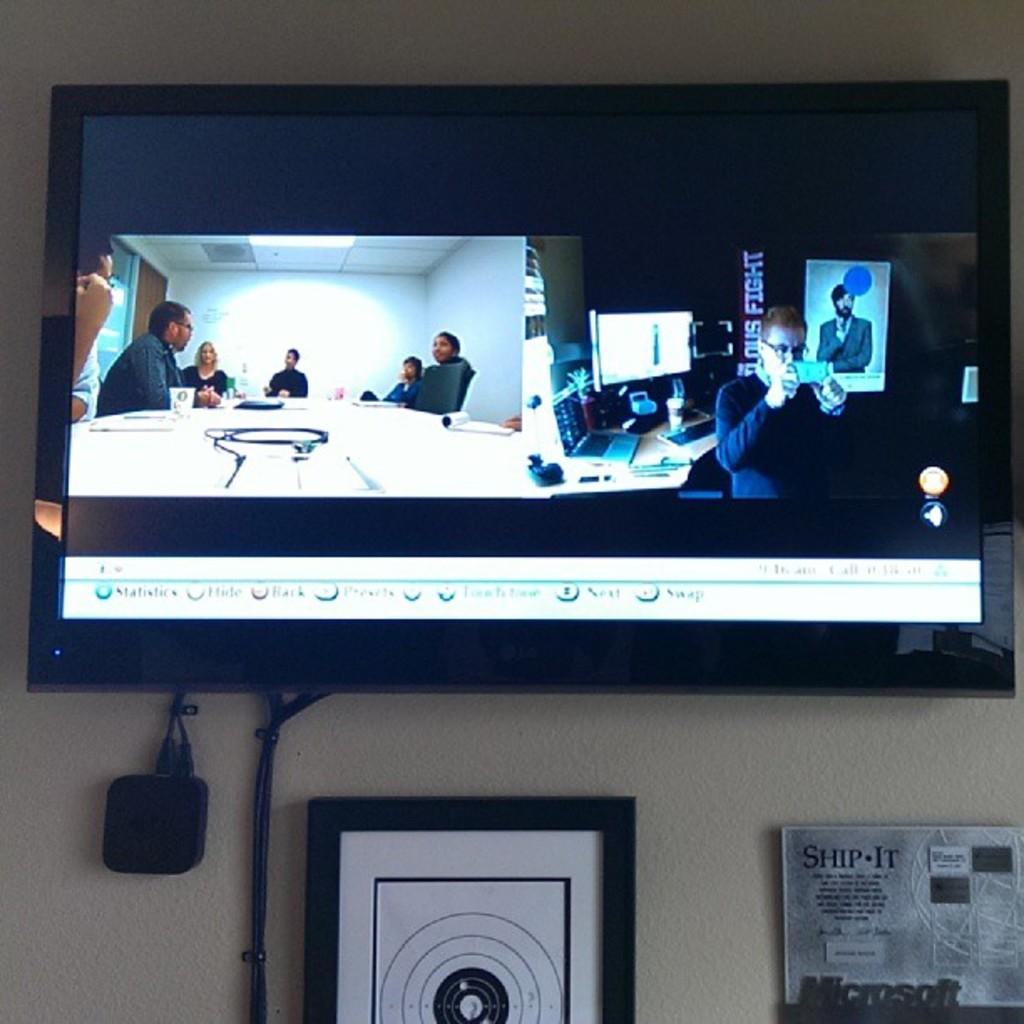<image>
Offer a succinct explanation of the picture presented. the word next on the bottom of some screen 